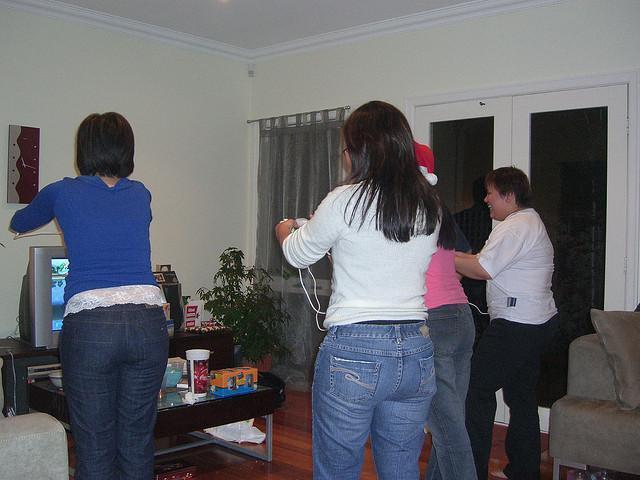How many people are there?
Give a very brief answer. 4. How many couches are there?
Give a very brief answer. 2. How many potted plants can be seen?
Give a very brief answer. 1. How many cows are present in this image?
Give a very brief answer. 0. 